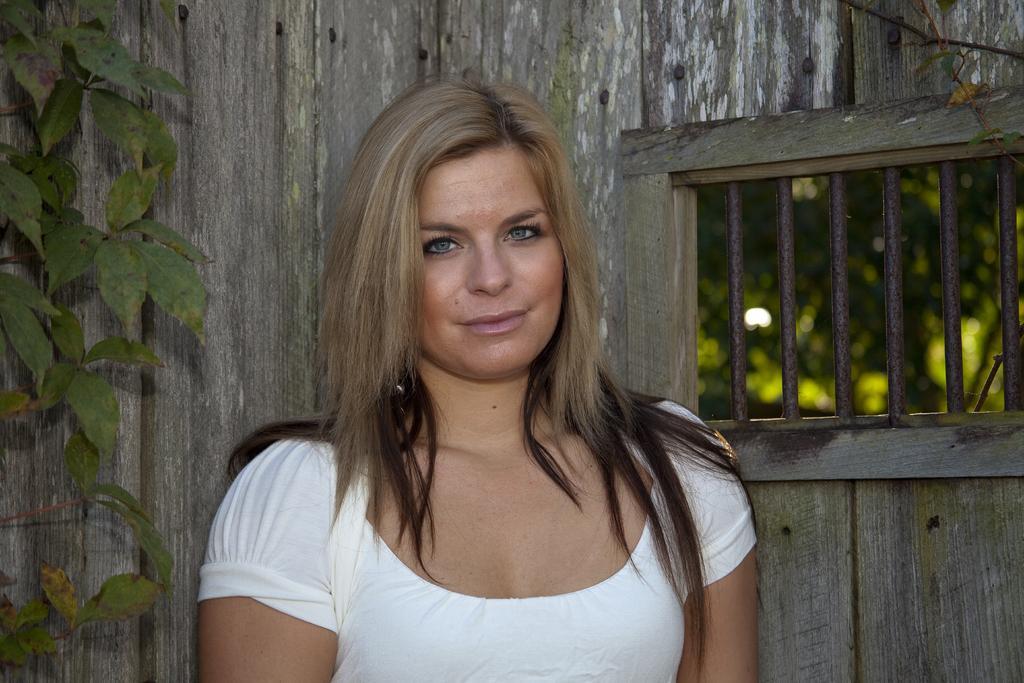Could you give a brief overview of what you see in this image? In this image there is one woman standing in middle of this image is wearing white color dress ,and there is one tree on the left side of this image and there is a wall in the background. There is a window on the right side of this image. 